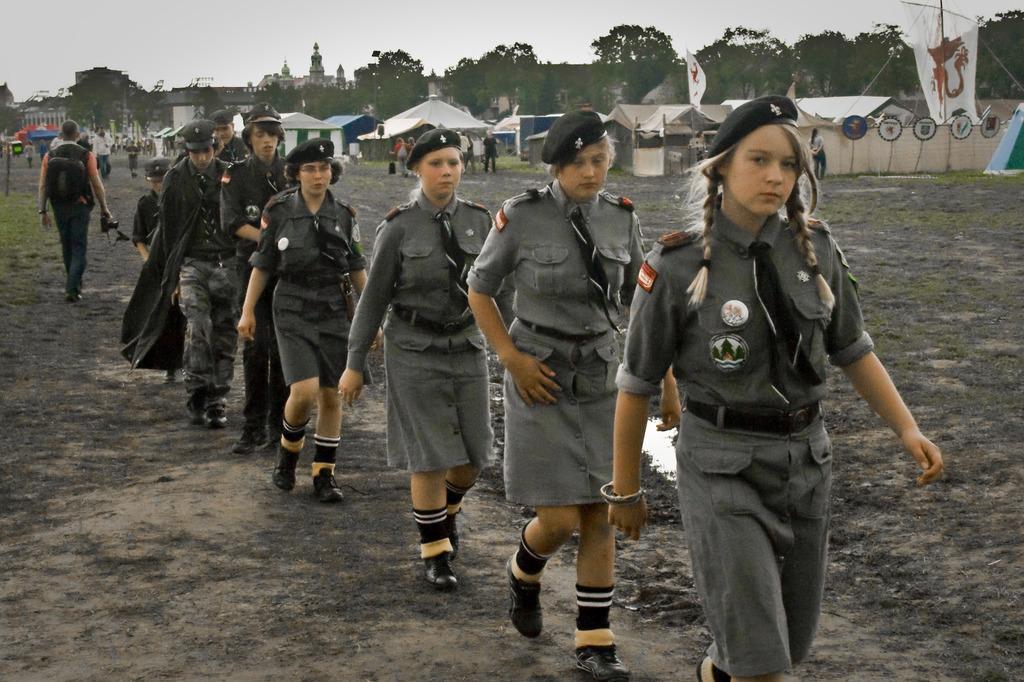Describe this image in one or two sentences. In this image I can see people walking, wearing a uniform. There are canopies, flags, trees and buildings at the back. There is sky at the top. 